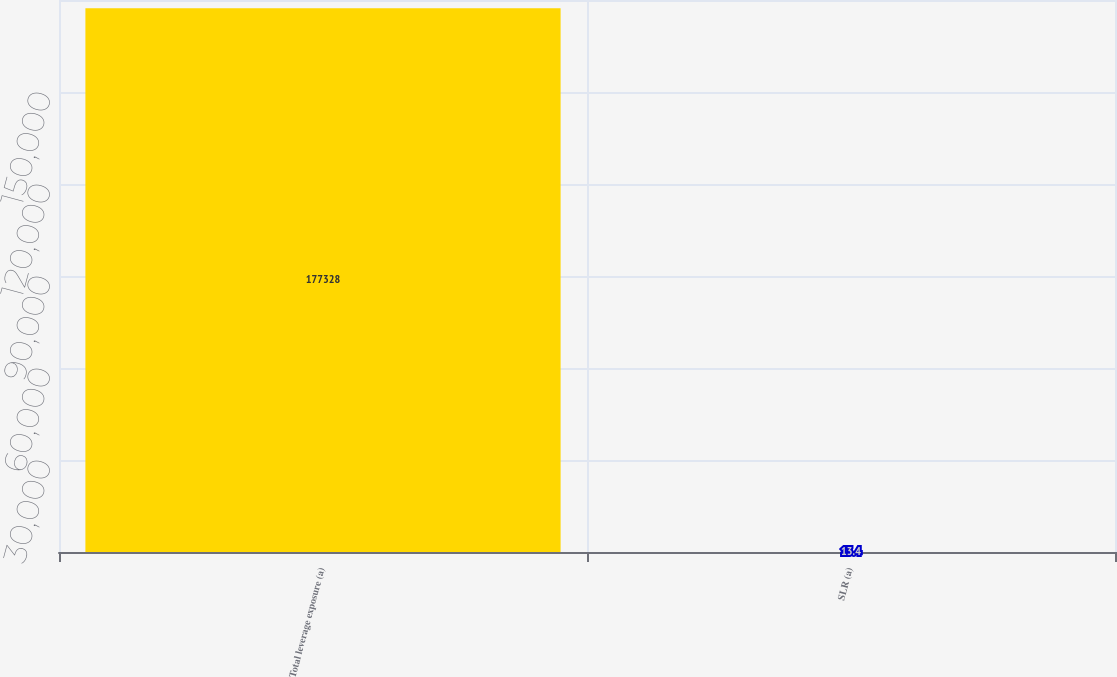<chart> <loc_0><loc_0><loc_500><loc_500><bar_chart><fcel>Total leverage exposure (a)<fcel>SLR (a)<nl><fcel>177328<fcel>13.4<nl></chart> 